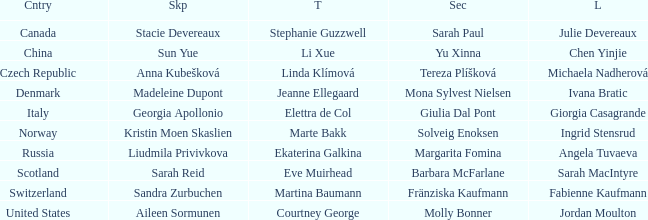What skip has angela tuvaeva as the lead? Liudmila Privivkova. 